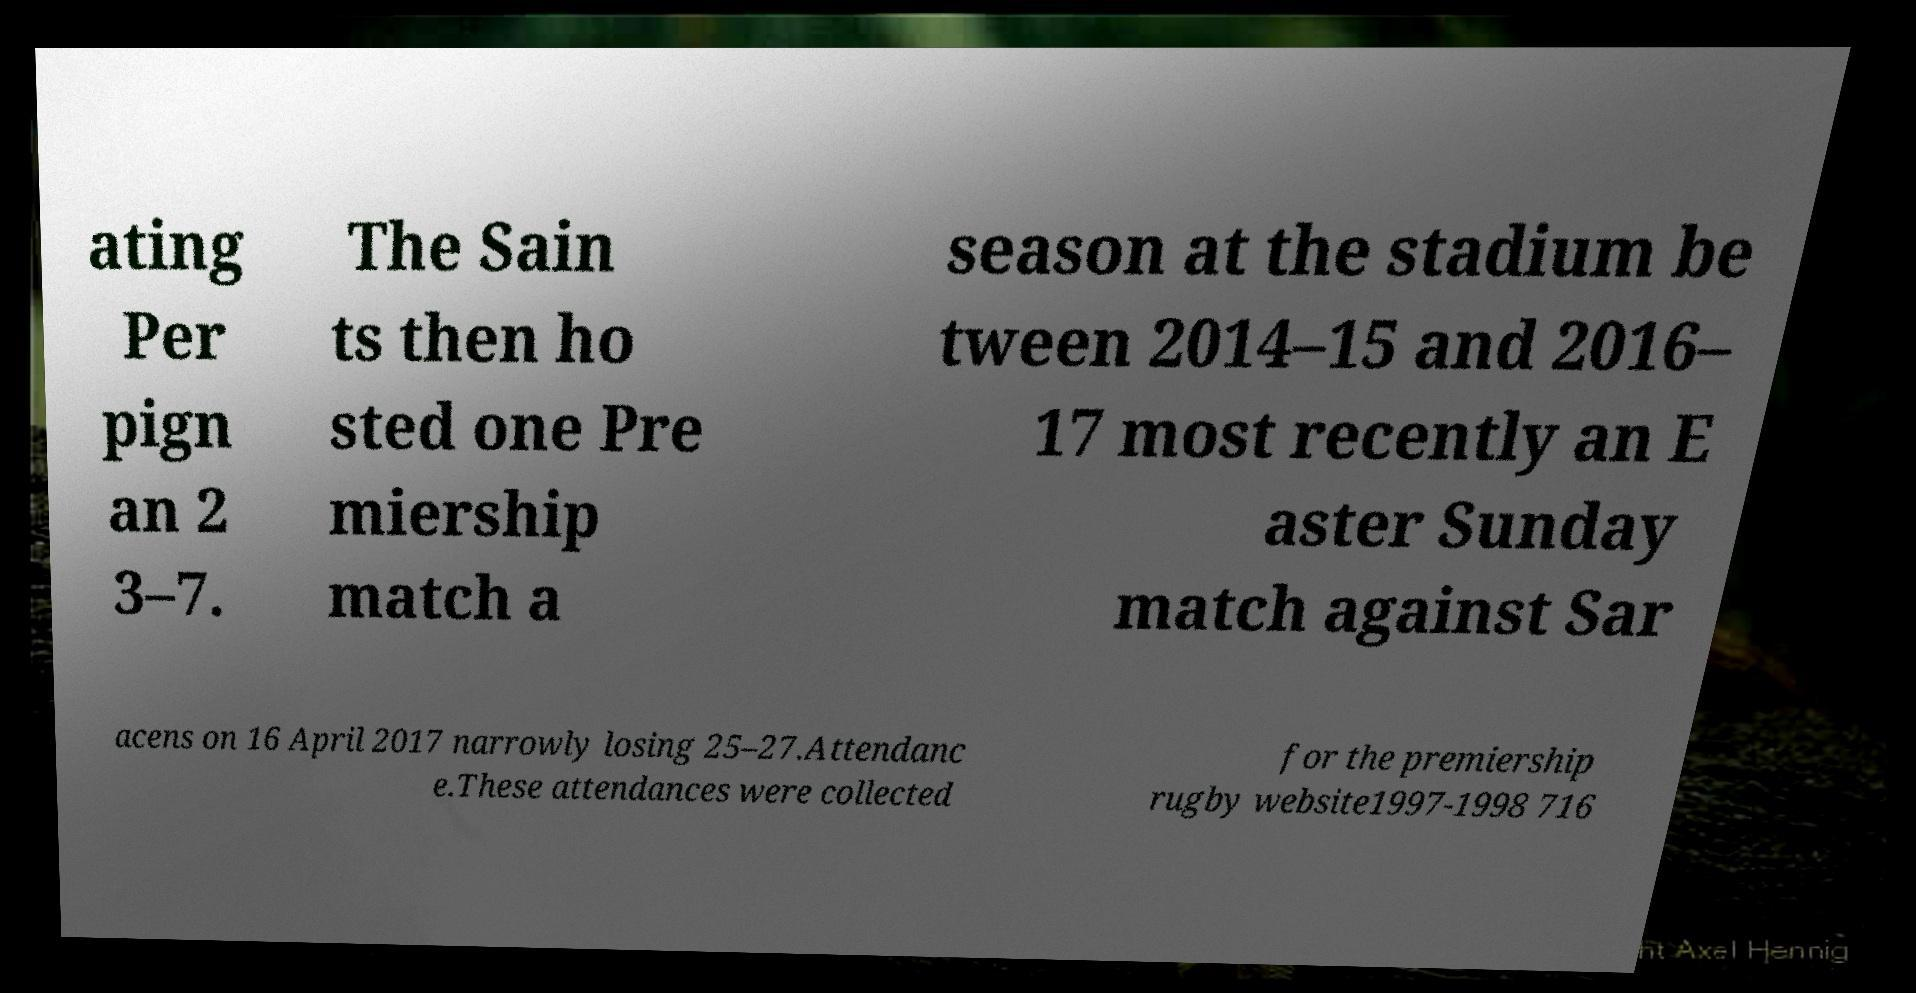For documentation purposes, I need the text within this image transcribed. Could you provide that? ating Per pign an 2 3–7. The Sain ts then ho sted one Pre miership match a season at the stadium be tween 2014–15 and 2016– 17 most recently an E aster Sunday match against Sar acens on 16 April 2017 narrowly losing 25–27.Attendanc e.These attendances were collected for the premiership rugby website1997-1998 716 